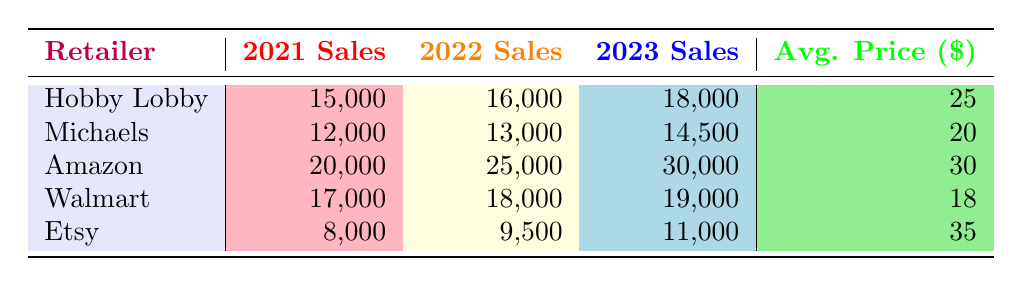What retailer had the highest sales in 2023? By looking at the sales column for 2023, we find that Amazon has the highest sales figure, which is 30,000.
Answer: Amazon What were Michaels' sales in 2022? Referring directly to the sales column for Michaels in 2022, it shows 13,000.
Answer: 13,000 Which retailer had the lowest average price for miniature models? Checking the average price column, Walmart has the lowest average price at 18.
Answer: Walmart What is the total sales for Hobby Lobby over the three years? To calculate the total sales for Hobby Lobby, we sum the sales figures: 15,000 (2021) + 16,000 (2022) + 18,000 (2023) = 49,000.
Answer: 49,000 Is it true that Etsy had more sales in 2022 than Hobby Lobby? Looking at the sales figures, Hobby Lobby had 16,000 in 2022, while Etsy had 9,500, so it is false that Etsy had more sales.
Answer: No What is the average annual sales for Amazon over the years provided? We find Amazon's total sales: 20,000 (2021) + 25,000 (2022) + 30,000 (2023) = 75,000. Then we divide by 3, giving an average of 25,000.
Answer: 25,000 Did Hobby Lobby's sales increase every year from 2021 to 2023? Observing the sales figures for Hobby Lobby; they increased from 15,000 in 2021 to 16,000 in 2022, and 18,000 in 2023, indicating a consistent yearly increase.
Answer: Yes Which retailer had the greatest increase in sales from 2021 to 2023? We calculate the increase for each retailer: Hobby Lobby: 3,000, Michaels: 2,500, Amazon: 10,000, Walmart: 2,000, and Etsy: 3,000. The greatest increase is from Amazon with 10,000.
Answer: Amazon What is the difference in sales between Walmart in 2023 and Michaels in 2021? Walmart had sales of 19,000 in 2023, and Michaels had sales of 12,000 in 2021. The difference is 19,000 - 12,000 = 7,000.
Answer: 7,000 